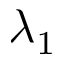Convert formula to latex. <formula><loc_0><loc_0><loc_500><loc_500>\lambda _ { 1 }</formula> 